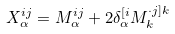Convert formula to latex. <formula><loc_0><loc_0><loc_500><loc_500>X _ { \alpha } ^ { i j } = M _ { \alpha } ^ { i j } + 2 \delta _ { \alpha } ^ { [ i } M _ { k } ^ { \cdot j ] k }</formula> 